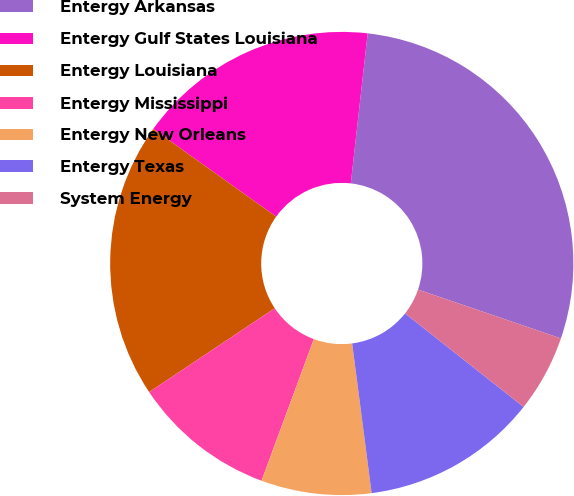Convert chart to OTSL. <chart><loc_0><loc_0><loc_500><loc_500><pie_chart><fcel>Entergy Arkansas<fcel>Entergy Gulf States Louisiana<fcel>Entergy Louisiana<fcel>Entergy Mississippi<fcel>Entergy New Orleans<fcel>Entergy Texas<fcel>System Energy<nl><fcel>28.46%<fcel>16.92%<fcel>19.23%<fcel>10.0%<fcel>7.69%<fcel>12.31%<fcel>5.39%<nl></chart> 